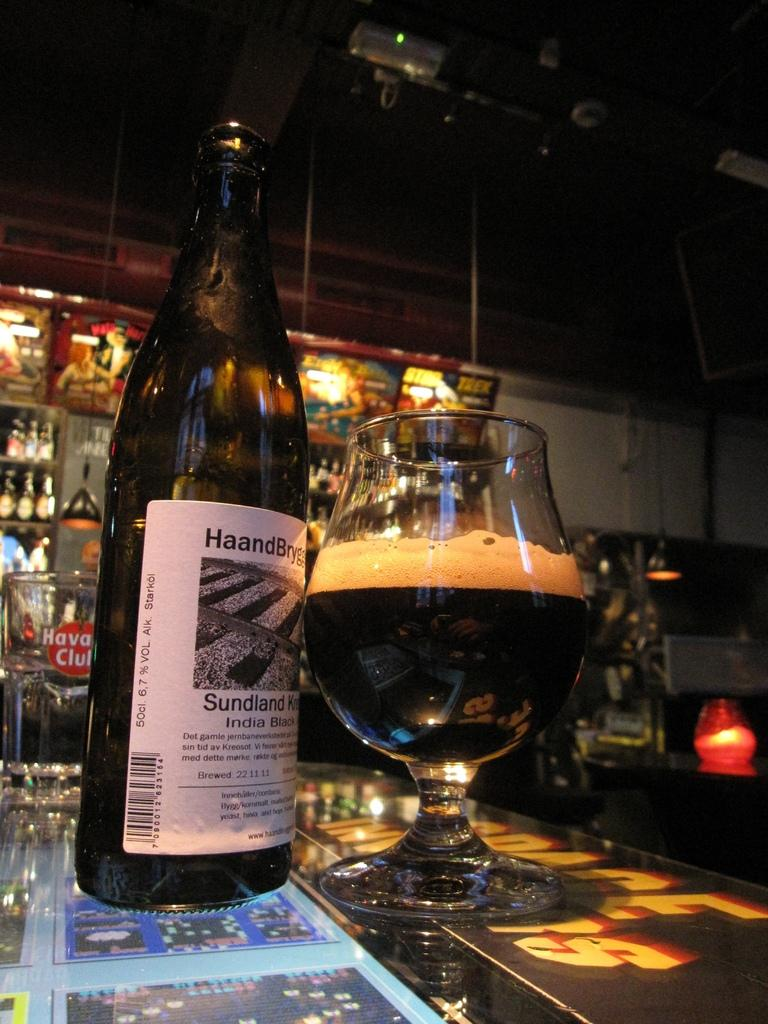What is present on the table in the image? There is a glass with a drink inside it and a bottle on the table. Can you describe the contents of the glass? The glass contains a drink. How many bottles are visible on the table? There is one bottle visible on the table. What can be seen in the background of the image? There are many bottles and light visible in the background of the image. What type of gold jewelry is the son wearing in the image? There is no son or gold jewelry present in the image. 